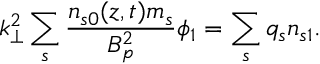Convert formula to latex. <formula><loc_0><loc_0><loc_500><loc_500>k _ { \perp } ^ { 2 } \sum _ { s } \frac { n _ { s 0 } ( z , t ) m _ { s } } { B _ { p } ^ { 2 } } \phi _ { 1 } = \sum _ { s } q _ { s } n _ { s 1 } .</formula> 